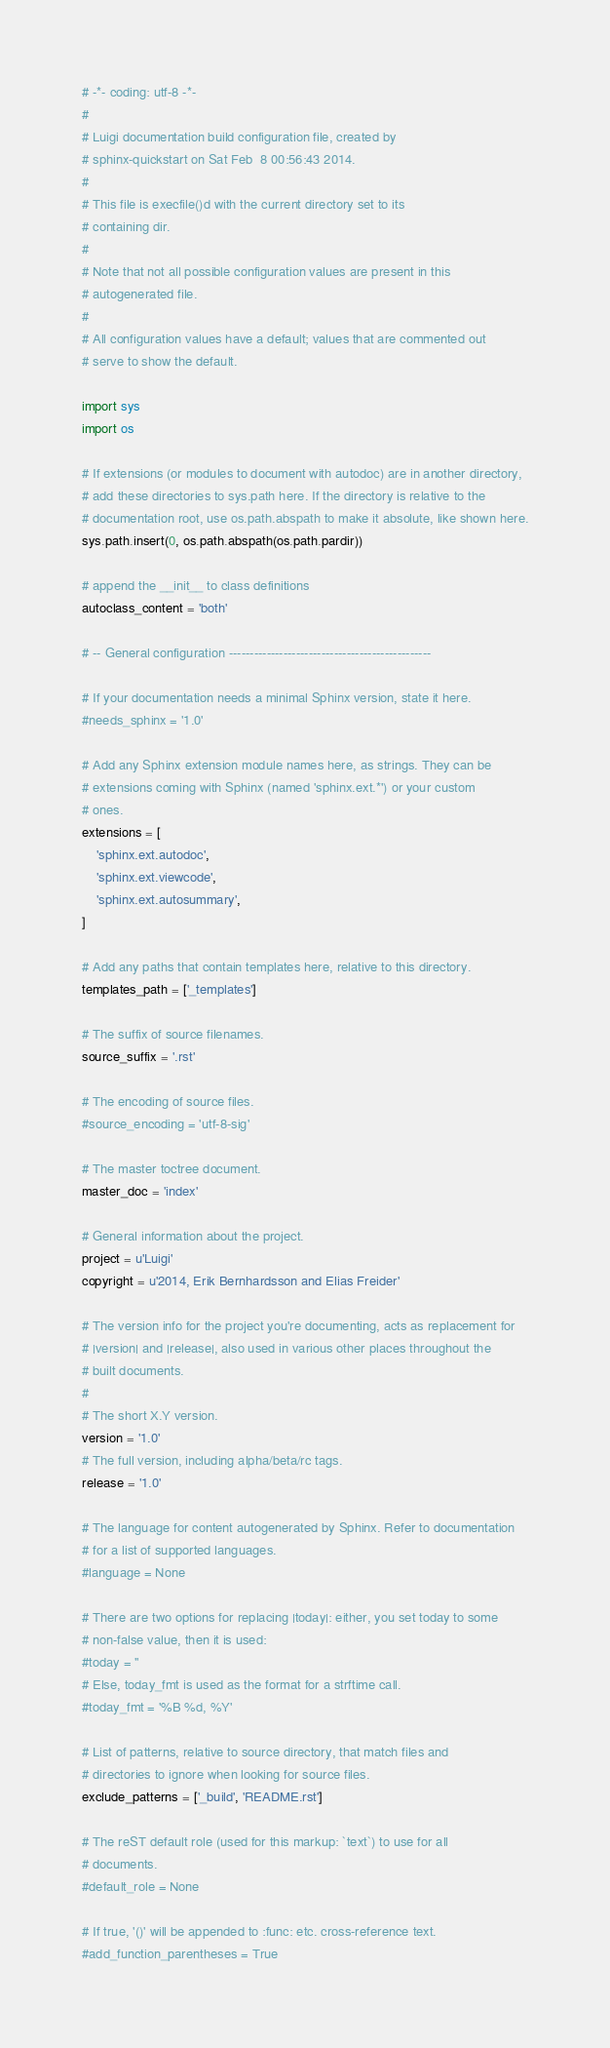<code> <loc_0><loc_0><loc_500><loc_500><_Python_># -*- coding: utf-8 -*-
#
# Luigi documentation build configuration file, created by
# sphinx-quickstart on Sat Feb  8 00:56:43 2014.
#
# This file is execfile()d with the current directory set to its
# containing dir.
#
# Note that not all possible configuration values are present in this
# autogenerated file.
#
# All configuration values have a default; values that are commented out
# serve to show the default.

import sys
import os

# If extensions (or modules to document with autodoc) are in another directory,
# add these directories to sys.path here. If the directory is relative to the
# documentation root, use os.path.abspath to make it absolute, like shown here.
sys.path.insert(0, os.path.abspath(os.path.pardir))

# append the __init__ to class definitions
autoclass_content = 'both'

# -- General configuration ------------------------------------------------

# If your documentation needs a minimal Sphinx version, state it here.
#needs_sphinx = '1.0'

# Add any Sphinx extension module names here, as strings. They can be
# extensions coming with Sphinx (named 'sphinx.ext.*') or your custom
# ones.
extensions = [
    'sphinx.ext.autodoc',
    'sphinx.ext.viewcode',
    'sphinx.ext.autosummary',
]

# Add any paths that contain templates here, relative to this directory.
templates_path = ['_templates']

# The suffix of source filenames.
source_suffix = '.rst'

# The encoding of source files.
#source_encoding = 'utf-8-sig'

# The master toctree document.
master_doc = 'index'

# General information about the project.
project = u'Luigi'
copyright = u'2014, Erik Bernhardsson and Elias Freider'

# The version info for the project you're documenting, acts as replacement for
# |version| and |release|, also used in various other places throughout the
# built documents.
#
# The short X.Y version.
version = '1.0'
# The full version, including alpha/beta/rc tags.
release = '1.0'

# The language for content autogenerated by Sphinx. Refer to documentation
# for a list of supported languages.
#language = None

# There are two options for replacing |today|: either, you set today to some
# non-false value, then it is used:
#today = ''
# Else, today_fmt is used as the format for a strftime call.
#today_fmt = '%B %d, %Y'

# List of patterns, relative to source directory, that match files and
# directories to ignore when looking for source files.
exclude_patterns = ['_build', 'README.rst']

# The reST default role (used for this markup: `text`) to use for all
# documents.
#default_role = None

# If true, '()' will be appended to :func: etc. cross-reference text.
#add_function_parentheses = True
</code> 